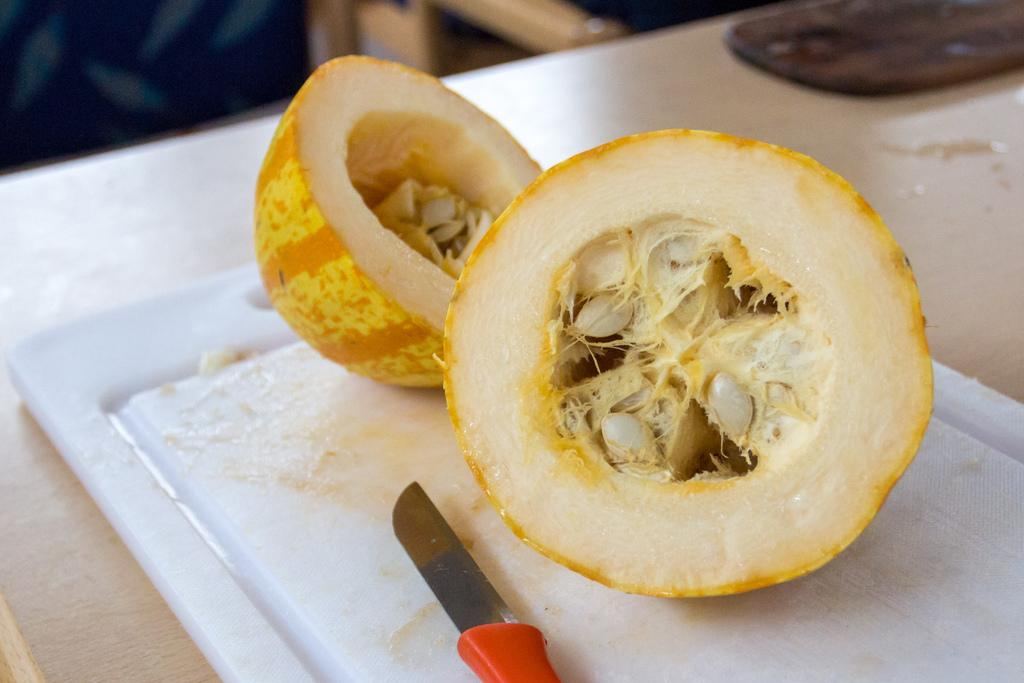What type of food item is present in the image? There is a vegetable in the image. How is the vegetable being supported or held in the image? The vegetable is on a plastic object. What utensil can be seen in the image? There is a knife in the image. What type of surface is visible in the image? There is a wooden table in the image. What type of dress is the vegetable wearing in the image? There is no dress present in the image, as vegetables do not wear clothing. 